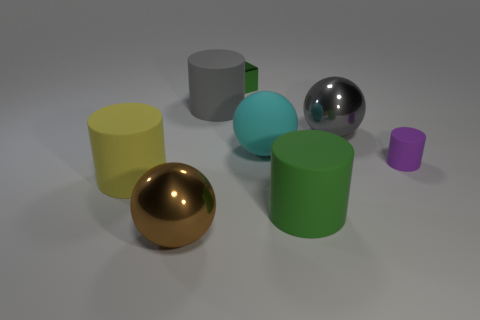Subtract 1 cylinders. How many cylinders are left? 3 Add 1 large green metallic cylinders. How many objects exist? 9 Subtract all spheres. How many objects are left? 5 Subtract 0 green balls. How many objects are left? 8 Subtract all big red rubber blocks. Subtract all big green matte objects. How many objects are left? 7 Add 6 large matte cylinders. How many large matte cylinders are left? 9 Add 1 tiny green shiny blocks. How many tiny green shiny blocks exist? 2 